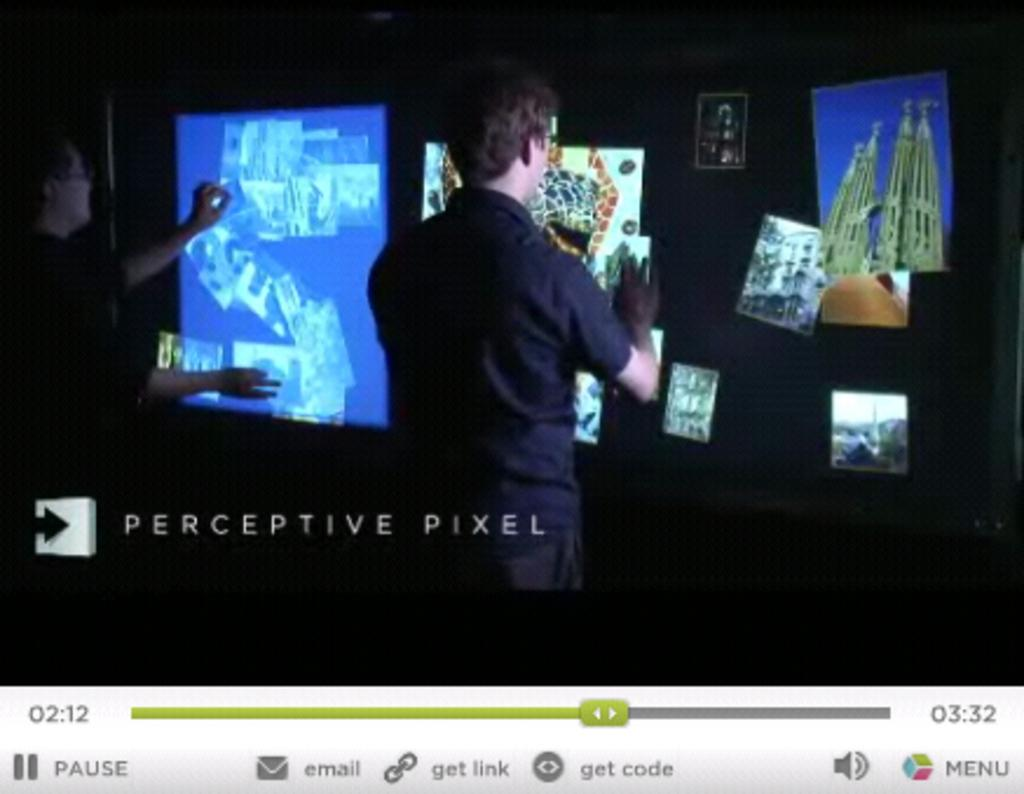<image>
Summarize the visual content of the image. A photo showing several photos that is labeled Perceptive Pixel. 